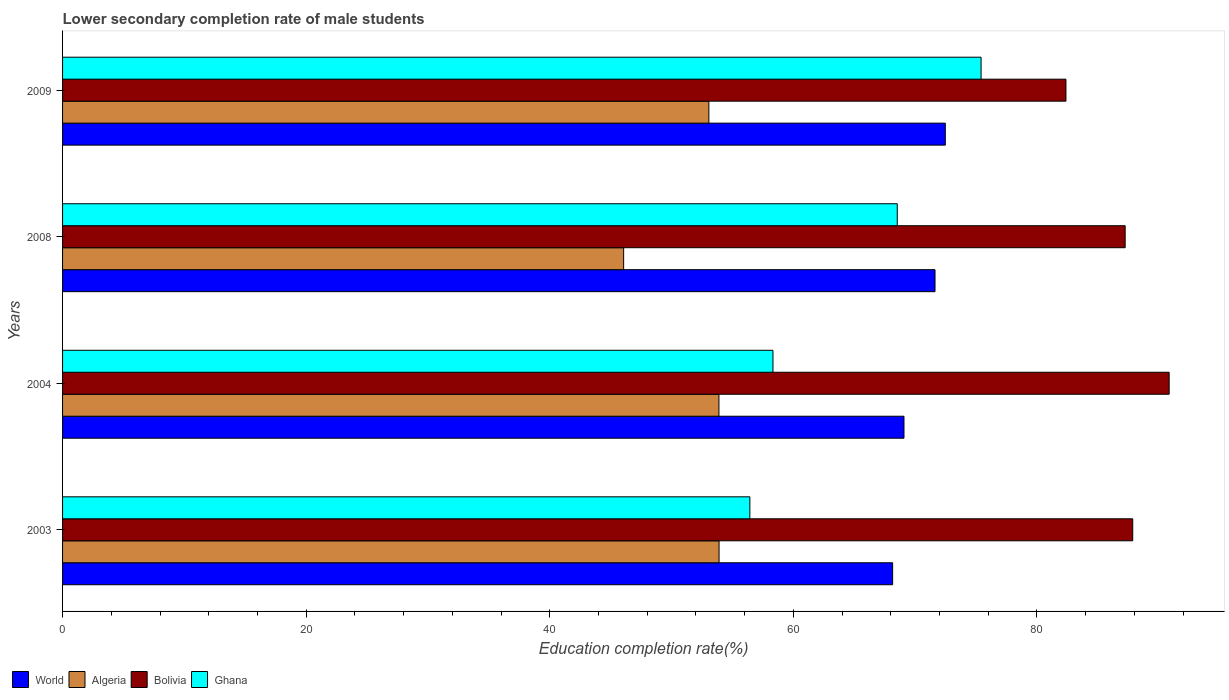Are the number of bars per tick equal to the number of legend labels?
Keep it short and to the point. Yes. Are the number of bars on each tick of the Y-axis equal?
Give a very brief answer. Yes. How many bars are there on the 4th tick from the top?
Your response must be concise. 4. What is the lower secondary completion rate of male students in World in 2009?
Ensure brevity in your answer.  72.48. Across all years, what is the maximum lower secondary completion rate of male students in Ghana?
Give a very brief answer. 75.41. Across all years, what is the minimum lower secondary completion rate of male students in Bolivia?
Your answer should be very brief. 82.38. In which year was the lower secondary completion rate of male students in Ghana maximum?
Your answer should be very brief. 2009. What is the total lower secondary completion rate of male students in Bolivia in the graph?
Offer a terse response. 348.34. What is the difference between the lower secondary completion rate of male students in Algeria in 2008 and that in 2009?
Offer a very short reply. -7. What is the difference between the lower secondary completion rate of male students in Algeria in 2009 and the lower secondary completion rate of male students in Bolivia in 2008?
Provide a succinct answer. -34.18. What is the average lower secondary completion rate of male students in Algeria per year?
Offer a very short reply. 51.73. In the year 2004, what is the difference between the lower secondary completion rate of male students in Ghana and lower secondary completion rate of male students in Bolivia?
Keep it short and to the point. -32.53. What is the ratio of the lower secondary completion rate of male students in Ghana in 2003 to that in 2008?
Your response must be concise. 0.82. Is the lower secondary completion rate of male students in Ghana in 2004 less than that in 2009?
Your answer should be compact. Yes. Is the difference between the lower secondary completion rate of male students in Ghana in 2004 and 2009 greater than the difference between the lower secondary completion rate of male students in Bolivia in 2004 and 2009?
Provide a short and direct response. No. What is the difference between the highest and the second highest lower secondary completion rate of male students in Bolivia?
Offer a very short reply. 2.99. What is the difference between the highest and the lowest lower secondary completion rate of male students in Algeria?
Provide a succinct answer. 7.83. Is the sum of the lower secondary completion rate of male students in Algeria in 2008 and 2009 greater than the maximum lower secondary completion rate of male students in Ghana across all years?
Give a very brief answer. Yes. Is it the case that in every year, the sum of the lower secondary completion rate of male students in World and lower secondary completion rate of male students in Algeria is greater than the sum of lower secondary completion rate of male students in Bolivia and lower secondary completion rate of male students in Ghana?
Your answer should be compact. No. Are all the bars in the graph horizontal?
Your answer should be compact. Yes. Are the values on the major ticks of X-axis written in scientific E-notation?
Make the answer very short. No. Does the graph contain any zero values?
Offer a very short reply. No. Where does the legend appear in the graph?
Offer a terse response. Bottom left. How are the legend labels stacked?
Your answer should be compact. Horizontal. What is the title of the graph?
Offer a terse response. Lower secondary completion rate of male students. Does "Seychelles" appear as one of the legend labels in the graph?
Your answer should be very brief. No. What is the label or title of the X-axis?
Keep it short and to the point. Education completion rate(%). What is the Education completion rate(%) in World in 2003?
Provide a succinct answer. 68.15. What is the Education completion rate(%) in Algeria in 2003?
Your answer should be compact. 53.9. What is the Education completion rate(%) of Bolivia in 2003?
Make the answer very short. 87.86. What is the Education completion rate(%) of Ghana in 2003?
Provide a short and direct response. 56.43. What is the Education completion rate(%) in World in 2004?
Ensure brevity in your answer.  69.08. What is the Education completion rate(%) in Algeria in 2004?
Offer a very short reply. 53.89. What is the Education completion rate(%) in Bolivia in 2004?
Offer a terse response. 90.86. What is the Education completion rate(%) of Ghana in 2004?
Your answer should be very brief. 58.33. What is the Education completion rate(%) of World in 2008?
Ensure brevity in your answer.  71.63. What is the Education completion rate(%) in Algeria in 2008?
Make the answer very short. 46.07. What is the Education completion rate(%) in Bolivia in 2008?
Give a very brief answer. 87.24. What is the Education completion rate(%) in Ghana in 2008?
Offer a very short reply. 68.53. What is the Education completion rate(%) of World in 2009?
Offer a terse response. 72.48. What is the Education completion rate(%) in Algeria in 2009?
Give a very brief answer. 53.06. What is the Education completion rate(%) in Bolivia in 2009?
Offer a terse response. 82.38. What is the Education completion rate(%) in Ghana in 2009?
Make the answer very short. 75.41. Across all years, what is the maximum Education completion rate(%) in World?
Provide a short and direct response. 72.48. Across all years, what is the maximum Education completion rate(%) of Algeria?
Your answer should be compact. 53.9. Across all years, what is the maximum Education completion rate(%) of Bolivia?
Offer a terse response. 90.86. Across all years, what is the maximum Education completion rate(%) in Ghana?
Offer a terse response. 75.41. Across all years, what is the minimum Education completion rate(%) of World?
Your answer should be very brief. 68.15. Across all years, what is the minimum Education completion rate(%) in Algeria?
Your answer should be compact. 46.07. Across all years, what is the minimum Education completion rate(%) of Bolivia?
Offer a very short reply. 82.38. Across all years, what is the minimum Education completion rate(%) in Ghana?
Offer a terse response. 56.43. What is the total Education completion rate(%) of World in the graph?
Give a very brief answer. 281.34. What is the total Education completion rate(%) in Algeria in the graph?
Provide a succinct answer. 206.92. What is the total Education completion rate(%) in Bolivia in the graph?
Provide a succinct answer. 348.34. What is the total Education completion rate(%) of Ghana in the graph?
Your answer should be compact. 258.7. What is the difference between the Education completion rate(%) of World in 2003 and that in 2004?
Provide a short and direct response. -0.93. What is the difference between the Education completion rate(%) in Algeria in 2003 and that in 2004?
Provide a short and direct response. 0.01. What is the difference between the Education completion rate(%) of Bolivia in 2003 and that in 2004?
Your answer should be compact. -2.99. What is the difference between the Education completion rate(%) of Ghana in 2003 and that in 2004?
Your answer should be very brief. -1.9. What is the difference between the Education completion rate(%) in World in 2003 and that in 2008?
Offer a terse response. -3.48. What is the difference between the Education completion rate(%) of Algeria in 2003 and that in 2008?
Ensure brevity in your answer.  7.83. What is the difference between the Education completion rate(%) in Bolivia in 2003 and that in 2008?
Your answer should be compact. 0.62. What is the difference between the Education completion rate(%) in Ghana in 2003 and that in 2008?
Ensure brevity in your answer.  -12.1. What is the difference between the Education completion rate(%) in World in 2003 and that in 2009?
Make the answer very short. -4.32. What is the difference between the Education completion rate(%) in Algeria in 2003 and that in 2009?
Your answer should be very brief. 0.84. What is the difference between the Education completion rate(%) in Bolivia in 2003 and that in 2009?
Keep it short and to the point. 5.48. What is the difference between the Education completion rate(%) in Ghana in 2003 and that in 2009?
Provide a succinct answer. -18.98. What is the difference between the Education completion rate(%) in World in 2004 and that in 2008?
Make the answer very short. -2.55. What is the difference between the Education completion rate(%) in Algeria in 2004 and that in 2008?
Provide a short and direct response. 7.82. What is the difference between the Education completion rate(%) in Bolivia in 2004 and that in 2008?
Offer a very short reply. 3.61. What is the difference between the Education completion rate(%) of Ghana in 2004 and that in 2008?
Give a very brief answer. -10.21. What is the difference between the Education completion rate(%) in World in 2004 and that in 2009?
Offer a very short reply. -3.39. What is the difference between the Education completion rate(%) of Algeria in 2004 and that in 2009?
Keep it short and to the point. 0.83. What is the difference between the Education completion rate(%) in Bolivia in 2004 and that in 2009?
Make the answer very short. 8.47. What is the difference between the Education completion rate(%) of Ghana in 2004 and that in 2009?
Offer a very short reply. -17.09. What is the difference between the Education completion rate(%) of World in 2008 and that in 2009?
Provide a succinct answer. -0.84. What is the difference between the Education completion rate(%) in Algeria in 2008 and that in 2009?
Your answer should be very brief. -7. What is the difference between the Education completion rate(%) of Bolivia in 2008 and that in 2009?
Your answer should be compact. 4.86. What is the difference between the Education completion rate(%) of Ghana in 2008 and that in 2009?
Ensure brevity in your answer.  -6.88. What is the difference between the Education completion rate(%) in World in 2003 and the Education completion rate(%) in Algeria in 2004?
Offer a terse response. 14.26. What is the difference between the Education completion rate(%) of World in 2003 and the Education completion rate(%) of Bolivia in 2004?
Keep it short and to the point. -22.7. What is the difference between the Education completion rate(%) in World in 2003 and the Education completion rate(%) in Ghana in 2004?
Your answer should be compact. 9.83. What is the difference between the Education completion rate(%) of Algeria in 2003 and the Education completion rate(%) of Bolivia in 2004?
Ensure brevity in your answer.  -36.95. What is the difference between the Education completion rate(%) in Algeria in 2003 and the Education completion rate(%) in Ghana in 2004?
Make the answer very short. -4.43. What is the difference between the Education completion rate(%) of Bolivia in 2003 and the Education completion rate(%) of Ghana in 2004?
Make the answer very short. 29.54. What is the difference between the Education completion rate(%) in World in 2003 and the Education completion rate(%) in Algeria in 2008?
Your response must be concise. 22.09. What is the difference between the Education completion rate(%) of World in 2003 and the Education completion rate(%) of Bolivia in 2008?
Ensure brevity in your answer.  -19.09. What is the difference between the Education completion rate(%) of World in 2003 and the Education completion rate(%) of Ghana in 2008?
Provide a short and direct response. -0.38. What is the difference between the Education completion rate(%) in Algeria in 2003 and the Education completion rate(%) in Bolivia in 2008?
Your answer should be very brief. -33.34. What is the difference between the Education completion rate(%) of Algeria in 2003 and the Education completion rate(%) of Ghana in 2008?
Offer a terse response. -14.63. What is the difference between the Education completion rate(%) of Bolivia in 2003 and the Education completion rate(%) of Ghana in 2008?
Make the answer very short. 19.33. What is the difference between the Education completion rate(%) of World in 2003 and the Education completion rate(%) of Algeria in 2009?
Your answer should be compact. 15.09. What is the difference between the Education completion rate(%) in World in 2003 and the Education completion rate(%) in Bolivia in 2009?
Your response must be concise. -14.23. What is the difference between the Education completion rate(%) of World in 2003 and the Education completion rate(%) of Ghana in 2009?
Make the answer very short. -7.26. What is the difference between the Education completion rate(%) of Algeria in 2003 and the Education completion rate(%) of Bolivia in 2009?
Your answer should be very brief. -28.48. What is the difference between the Education completion rate(%) in Algeria in 2003 and the Education completion rate(%) in Ghana in 2009?
Offer a very short reply. -21.51. What is the difference between the Education completion rate(%) of Bolivia in 2003 and the Education completion rate(%) of Ghana in 2009?
Your answer should be very brief. 12.45. What is the difference between the Education completion rate(%) in World in 2004 and the Education completion rate(%) in Algeria in 2008?
Provide a succinct answer. 23.02. What is the difference between the Education completion rate(%) in World in 2004 and the Education completion rate(%) in Bolivia in 2008?
Ensure brevity in your answer.  -18.16. What is the difference between the Education completion rate(%) of World in 2004 and the Education completion rate(%) of Ghana in 2008?
Offer a very short reply. 0.55. What is the difference between the Education completion rate(%) in Algeria in 2004 and the Education completion rate(%) in Bolivia in 2008?
Your answer should be very brief. -33.35. What is the difference between the Education completion rate(%) of Algeria in 2004 and the Education completion rate(%) of Ghana in 2008?
Offer a very short reply. -14.64. What is the difference between the Education completion rate(%) in Bolivia in 2004 and the Education completion rate(%) in Ghana in 2008?
Provide a succinct answer. 22.32. What is the difference between the Education completion rate(%) of World in 2004 and the Education completion rate(%) of Algeria in 2009?
Your answer should be very brief. 16.02. What is the difference between the Education completion rate(%) in World in 2004 and the Education completion rate(%) in Bolivia in 2009?
Provide a succinct answer. -13.3. What is the difference between the Education completion rate(%) of World in 2004 and the Education completion rate(%) of Ghana in 2009?
Give a very brief answer. -6.33. What is the difference between the Education completion rate(%) in Algeria in 2004 and the Education completion rate(%) in Bolivia in 2009?
Offer a very short reply. -28.49. What is the difference between the Education completion rate(%) in Algeria in 2004 and the Education completion rate(%) in Ghana in 2009?
Offer a terse response. -21.52. What is the difference between the Education completion rate(%) in Bolivia in 2004 and the Education completion rate(%) in Ghana in 2009?
Provide a short and direct response. 15.44. What is the difference between the Education completion rate(%) in World in 2008 and the Education completion rate(%) in Algeria in 2009?
Offer a terse response. 18.57. What is the difference between the Education completion rate(%) of World in 2008 and the Education completion rate(%) of Bolivia in 2009?
Make the answer very short. -10.75. What is the difference between the Education completion rate(%) of World in 2008 and the Education completion rate(%) of Ghana in 2009?
Offer a terse response. -3.78. What is the difference between the Education completion rate(%) of Algeria in 2008 and the Education completion rate(%) of Bolivia in 2009?
Provide a succinct answer. -36.32. What is the difference between the Education completion rate(%) in Algeria in 2008 and the Education completion rate(%) in Ghana in 2009?
Make the answer very short. -29.35. What is the difference between the Education completion rate(%) in Bolivia in 2008 and the Education completion rate(%) in Ghana in 2009?
Ensure brevity in your answer.  11.83. What is the average Education completion rate(%) of World per year?
Your response must be concise. 70.34. What is the average Education completion rate(%) of Algeria per year?
Provide a succinct answer. 51.73. What is the average Education completion rate(%) in Bolivia per year?
Ensure brevity in your answer.  87.09. What is the average Education completion rate(%) of Ghana per year?
Offer a very short reply. 64.67. In the year 2003, what is the difference between the Education completion rate(%) in World and Education completion rate(%) in Algeria?
Keep it short and to the point. 14.25. In the year 2003, what is the difference between the Education completion rate(%) of World and Education completion rate(%) of Bolivia?
Give a very brief answer. -19.71. In the year 2003, what is the difference between the Education completion rate(%) in World and Education completion rate(%) in Ghana?
Keep it short and to the point. 11.72. In the year 2003, what is the difference between the Education completion rate(%) of Algeria and Education completion rate(%) of Bolivia?
Ensure brevity in your answer.  -33.96. In the year 2003, what is the difference between the Education completion rate(%) of Algeria and Education completion rate(%) of Ghana?
Provide a short and direct response. -2.53. In the year 2003, what is the difference between the Education completion rate(%) in Bolivia and Education completion rate(%) in Ghana?
Offer a terse response. 31.44. In the year 2004, what is the difference between the Education completion rate(%) of World and Education completion rate(%) of Algeria?
Offer a very short reply. 15.19. In the year 2004, what is the difference between the Education completion rate(%) of World and Education completion rate(%) of Bolivia?
Your response must be concise. -21.77. In the year 2004, what is the difference between the Education completion rate(%) in World and Education completion rate(%) in Ghana?
Your answer should be very brief. 10.76. In the year 2004, what is the difference between the Education completion rate(%) in Algeria and Education completion rate(%) in Bolivia?
Give a very brief answer. -36.97. In the year 2004, what is the difference between the Education completion rate(%) in Algeria and Education completion rate(%) in Ghana?
Keep it short and to the point. -4.44. In the year 2004, what is the difference between the Education completion rate(%) in Bolivia and Education completion rate(%) in Ghana?
Give a very brief answer. 32.53. In the year 2008, what is the difference between the Education completion rate(%) in World and Education completion rate(%) in Algeria?
Make the answer very short. 25.57. In the year 2008, what is the difference between the Education completion rate(%) in World and Education completion rate(%) in Bolivia?
Your answer should be very brief. -15.61. In the year 2008, what is the difference between the Education completion rate(%) in World and Education completion rate(%) in Ghana?
Provide a succinct answer. 3.1. In the year 2008, what is the difference between the Education completion rate(%) of Algeria and Education completion rate(%) of Bolivia?
Provide a succinct answer. -41.18. In the year 2008, what is the difference between the Education completion rate(%) in Algeria and Education completion rate(%) in Ghana?
Offer a very short reply. -22.47. In the year 2008, what is the difference between the Education completion rate(%) of Bolivia and Education completion rate(%) of Ghana?
Give a very brief answer. 18.71. In the year 2009, what is the difference between the Education completion rate(%) of World and Education completion rate(%) of Algeria?
Your answer should be very brief. 19.41. In the year 2009, what is the difference between the Education completion rate(%) in World and Education completion rate(%) in Bolivia?
Provide a succinct answer. -9.91. In the year 2009, what is the difference between the Education completion rate(%) in World and Education completion rate(%) in Ghana?
Keep it short and to the point. -2.94. In the year 2009, what is the difference between the Education completion rate(%) of Algeria and Education completion rate(%) of Bolivia?
Your answer should be very brief. -29.32. In the year 2009, what is the difference between the Education completion rate(%) in Algeria and Education completion rate(%) in Ghana?
Offer a very short reply. -22.35. In the year 2009, what is the difference between the Education completion rate(%) of Bolivia and Education completion rate(%) of Ghana?
Your answer should be very brief. 6.97. What is the ratio of the Education completion rate(%) in World in 2003 to that in 2004?
Make the answer very short. 0.99. What is the ratio of the Education completion rate(%) in Algeria in 2003 to that in 2004?
Ensure brevity in your answer.  1. What is the ratio of the Education completion rate(%) of Bolivia in 2003 to that in 2004?
Ensure brevity in your answer.  0.97. What is the ratio of the Education completion rate(%) in Ghana in 2003 to that in 2004?
Offer a very short reply. 0.97. What is the ratio of the Education completion rate(%) of World in 2003 to that in 2008?
Offer a very short reply. 0.95. What is the ratio of the Education completion rate(%) in Algeria in 2003 to that in 2008?
Provide a short and direct response. 1.17. What is the ratio of the Education completion rate(%) of Bolivia in 2003 to that in 2008?
Your answer should be very brief. 1.01. What is the ratio of the Education completion rate(%) of Ghana in 2003 to that in 2008?
Offer a terse response. 0.82. What is the ratio of the Education completion rate(%) of World in 2003 to that in 2009?
Your answer should be compact. 0.94. What is the ratio of the Education completion rate(%) in Algeria in 2003 to that in 2009?
Offer a terse response. 1.02. What is the ratio of the Education completion rate(%) of Bolivia in 2003 to that in 2009?
Provide a succinct answer. 1.07. What is the ratio of the Education completion rate(%) in Ghana in 2003 to that in 2009?
Your response must be concise. 0.75. What is the ratio of the Education completion rate(%) of World in 2004 to that in 2008?
Your answer should be compact. 0.96. What is the ratio of the Education completion rate(%) of Algeria in 2004 to that in 2008?
Your answer should be very brief. 1.17. What is the ratio of the Education completion rate(%) of Bolivia in 2004 to that in 2008?
Ensure brevity in your answer.  1.04. What is the ratio of the Education completion rate(%) of Ghana in 2004 to that in 2008?
Your answer should be compact. 0.85. What is the ratio of the Education completion rate(%) of World in 2004 to that in 2009?
Ensure brevity in your answer.  0.95. What is the ratio of the Education completion rate(%) of Algeria in 2004 to that in 2009?
Offer a terse response. 1.02. What is the ratio of the Education completion rate(%) of Bolivia in 2004 to that in 2009?
Provide a short and direct response. 1.1. What is the ratio of the Education completion rate(%) of Ghana in 2004 to that in 2009?
Keep it short and to the point. 0.77. What is the ratio of the Education completion rate(%) of World in 2008 to that in 2009?
Provide a succinct answer. 0.99. What is the ratio of the Education completion rate(%) of Algeria in 2008 to that in 2009?
Give a very brief answer. 0.87. What is the ratio of the Education completion rate(%) in Bolivia in 2008 to that in 2009?
Give a very brief answer. 1.06. What is the ratio of the Education completion rate(%) in Ghana in 2008 to that in 2009?
Provide a short and direct response. 0.91. What is the difference between the highest and the second highest Education completion rate(%) of World?
Offer a very short reply. 0.84. What is the difference between the highest and the second highest Education completion rate(%) in Algeria?
Make the answer very short. 0.01. What is the difference between the highest and the second highest Education completion rate(%) in Bolivia?
Provide a short and direct response. 2.99. What is the difference between the highest and the second highest Education completion rate(%) of Ghana?
Provide a succinct answer. 6.88. What is the difference between the highest and the lowest Education completion rate(%) in World?
Your response must be concise. 4.32. What is the difference between the highest and the lowest Education completion rate(%) of Algeria?
Give a very brief answer. 7.83. What is the difference between the highest and the lowest Education completion rate(%) of Bolivia?
Provide a succinct answer. 8.47. What is the difference between the highest and the lowest Education completion rate(%) in Ghana?
Your answer should be very brief. 18.98. 